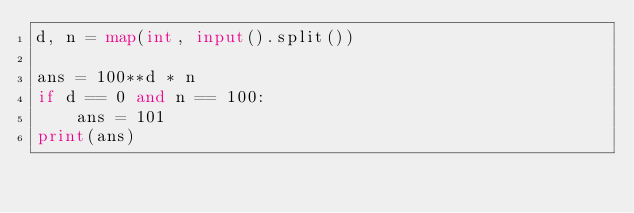<code> <loc_0><loc_0><loc_500><loc_500><_Python_>d, n = map(int, input().split())

ans = 100**d * n
if d == 0 and n == 100:
    ans = 101
print(ans)</code> 